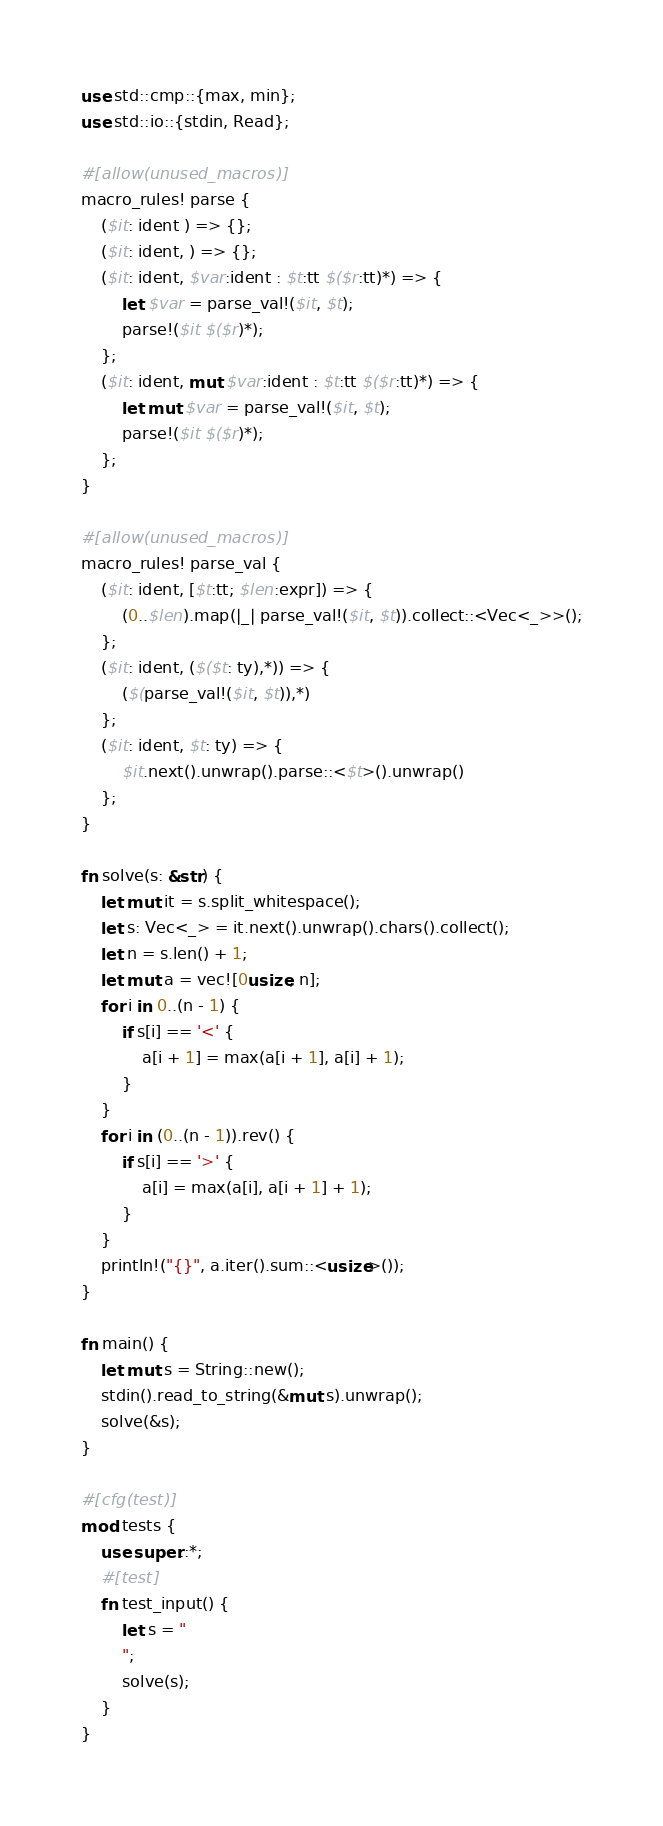<code> <loc_0><loc_0><loc_500><loc_500><_Rust_>use std::cmp::{max, min};
use std::io::{stdin, Read};

#[allow(unused_macros)]
macro_rules! parse {
    ($it: ident ) => {};
    ($it: ident, ) => {};
    ($it: ident, $var:ident : $t:tt $($r:tt)*) => {
        let $var = parse_val!($it, $t);
        parse!($it $($r)*);
    };
    ($it: ident, mut $var:ident : $t:tt $($r:tt)*) => {
        let mut $var = parse_val!($it, $t);
        parse!($it $($r)*);
    };
}

#[allow(unused_macros)]
macro_rules! parse_val {
    ($it: ident, [$t:tt; $len:expr]) => {
        (0..$len).map(|_| parse_val!($it, $t)).collect::<Vec<_>>();
    };
    ($it: ident, ($($t: ty),*)) => {
        ($(parse_val!($it, $t)),*)
    };
    ($it: ident, $t: ty) => {
        $it.next().unwrap().parse::<$t>().unwrap()
    };
}

fn solve(s: &str) {
    let mut it = s.split_whitespace();
    let s: Vec<_> = it.next().unwrap().chars().collect();
    let n = s.len() + 1;
    let mut a = vec![0usize; n];
    for i in 0..(n - 1) {
        if s[i] == '<' {
            a[i + 1] = max(a[i + 1], a[i] + 1);
        }
    }
    for i in (0..(n - 1)).rev() {
        if s[i] == '>' {
            a[i] = max(a[i], a[i + 1] + 1);
        }
    }
    println!("{}", a.iter().sum::<usize>());
}

fn main() {
    let mut s = String::new();
    stdin().read_to_string(&mut s).unwrap();
    solve(&s);
}

#[cfg(test)]
mod tests {
    use super::*;
    #[test]
    fn test_input() {
        let s = "
        ";
        solve(s);
    }
}
</code> 